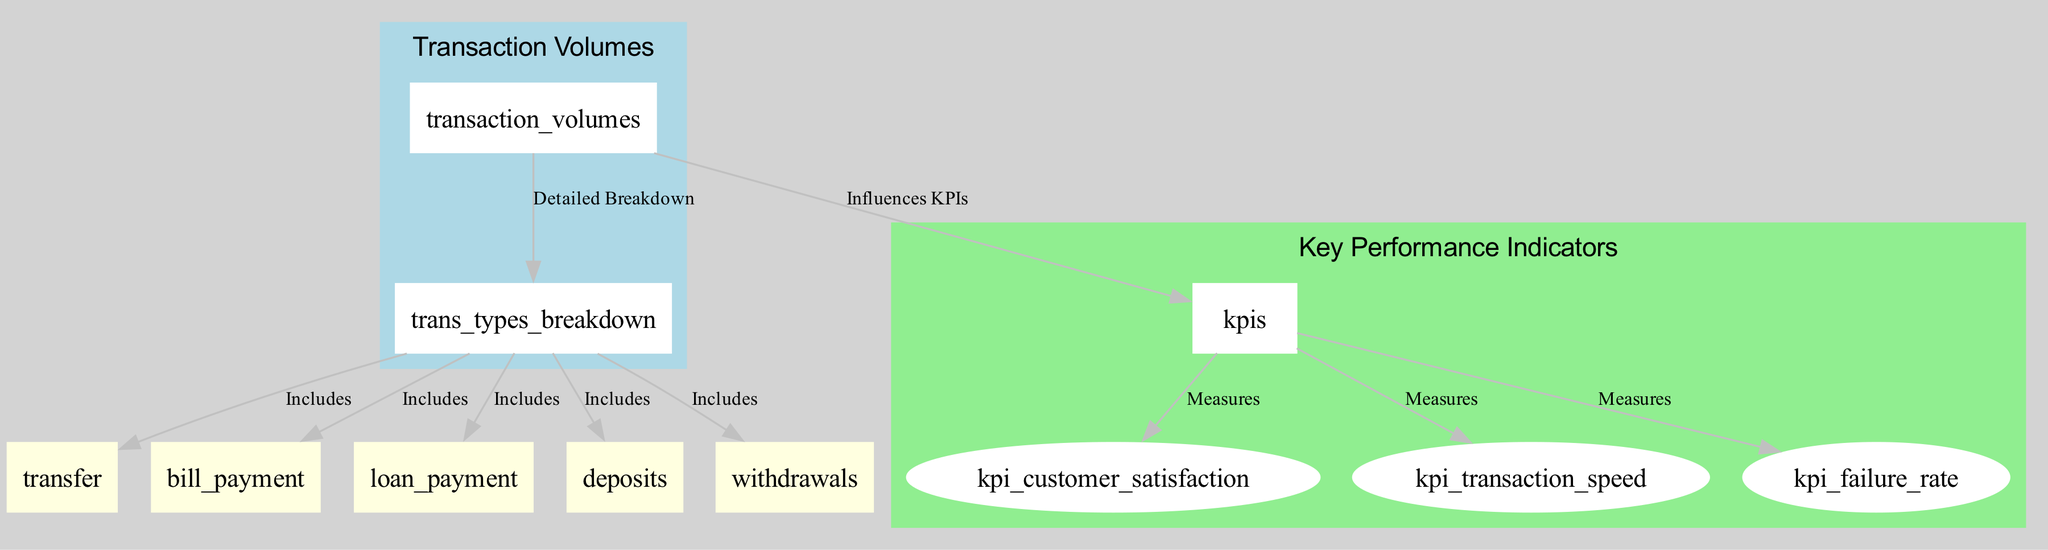What are the two main sections of the diagram? The diagram is divided into two main sections: "Transaction Volumes" and "Key Performance Indicators". This is visually represented through the cluster grouping of nodes and their labels, indicating the two key areas of focus.
Answer: Transaction Volumes, Key Performance Indicators How many types of transactions are included in the breakdown? The diagram shows a breakdown of five types of transactions: transfers, bill payments, loan payments, deposits, and withdrawals. This is visible through the labeled nodes grouped under "Types of Transactions".
Answer: Five What influence do transaction volumes have in the diagram? The diagram indicates that transaction volumes "influence KPIs". This is shown by the directed edge that connects "Transaction Volumes" to "Key Performance Indicators", highlighting the impact of transaction volumes on overall performance metrics.
Answer: Influence KPIs Which KPI directly measures customer satisfaction? In the KPIs section, "Customer Satisfaction" is highlighted as one of the three measures. This is evident from the directed edge that stems from the "kpis" node to "kpi_customer_satisfaction", indicating a direct measurement relationship.
Answer: Customer Satisfaction What type of relationship exists between transaction volumes and the types of transactions? The relationship is described as a "Detailed Breakdown". The directed edge connecting "Transaction Volumes" to "Types of Transactions" indicates that transaction volumes can be dissected to reveal individual transaction types.
Answer: Detailed Breakdown Which type of transaction is not included in the breakdown? The diagram specifically lists transfers, bill payments, loan payments, deposits, and withdrawals under "Types of Transactions", implying that any other type, such as online purchases or money orders, is not included. This can be inferred from the absence of such transaction types in the diagram.
Answer: Not applicable types like online purchases What is the purpose of the KPIs in relation to transaction volumes? The purpose of the KPIs is to measure aspects influenced by transaction volumes, including customer satisfaction, transaction speed, and failure rate. The directed relationships from the "kpis" node denote that KPIs serve as outcomes or metrics derived from transaction volumes.
Answer: Measures outcomes of transaction volumes How many edges are used to connect the KPIs to their respective expressions? There are three edges connecting "kpis" to its respective expressions: "kpi_customer_satisfaction", "kpi_transaction_speed", and "kpi_failure_rate". These edges indicate that each KPI represents a different measure related to the performance of digital banking transactions.
Answer: Three edges What color represents the "Transaction Volumes" section? The "Transaction Volumes" section is colored light blue, as indicated by its cluster attributes which define the visual aspect of that section in the diagram.
Answer: Light blue 